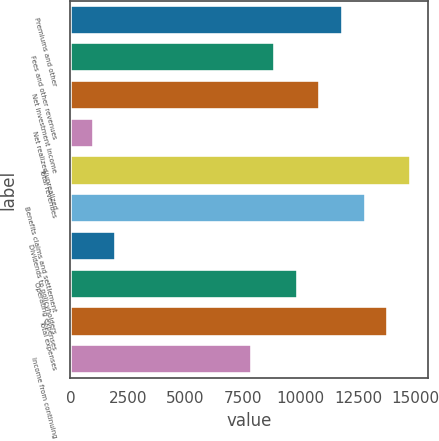Convert chart to OTSL. <chart><loc_0><loc_0><loc_500><loc_500><bar_chart><fcel>Premiums and other<fcel>Fees and other revenues<fcel>Net investment income<fcel>Net realized/unrealized<fcel>Total revenues<fcel>Benefits claims and settlement<fcel>Dividends to policyholders<fcel>Operating expenses<fcel>Total expenses<fcel>Income from continuing<nl><fcel>11838.5<fcel>8886.51<fcel>10854.5<fcel>1014.59<fcel>14790.5<fcel>12822.5<fcel>1998.58<fcel>9870.5<fcel>13806.5<fcel>7902.52<nl></chart> 